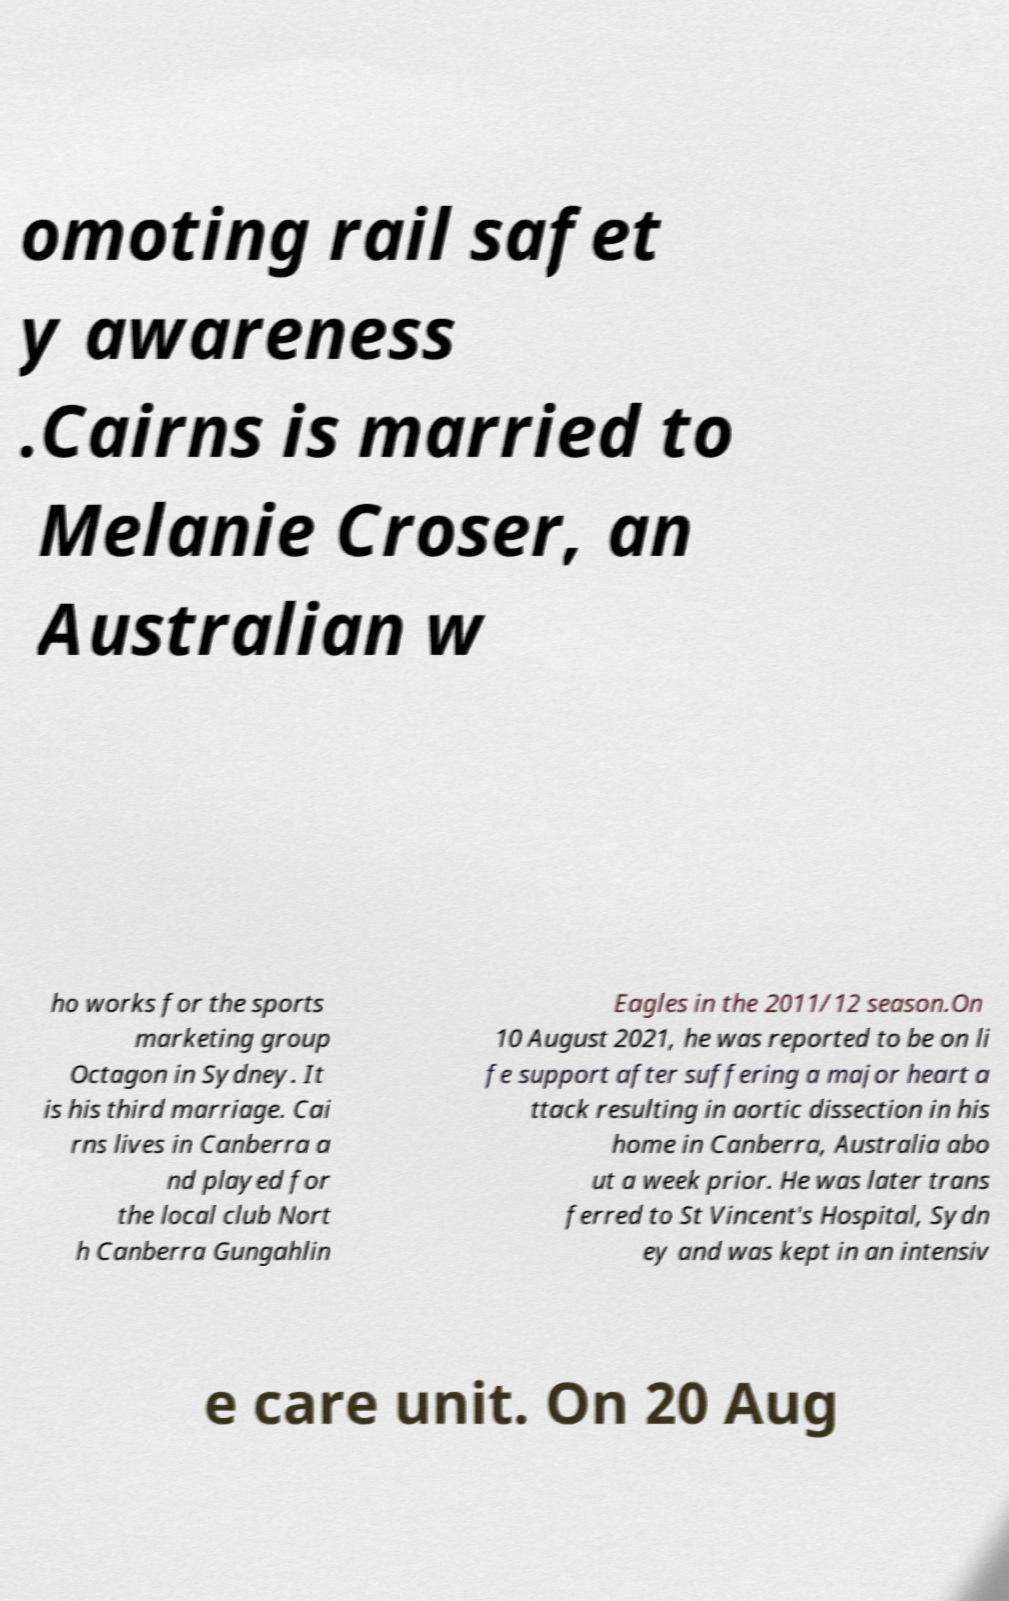Can you accurately transcribe the text from the provided image for me? omoting rail safet y awareness .Cairns is married to Melanie Croser, an Australian w ho works for the sports marketing group Octagon in Sydney. It is his third marriage. Cai rns lives in Canberra a nd played for the local club Nort h Canberra Gungahlin Eagles in the 2011/12 season.On 10 August 2021, he was reported to be on li fe support after suffering a major heart a ttack resulting in aortic dissection in his home in Canberra, Australia abo ut a week prior. He was later trans ferred to St Vincent's Hospital, Sydn ey and was kept in an intensiv e care unit. On 20 Aug 